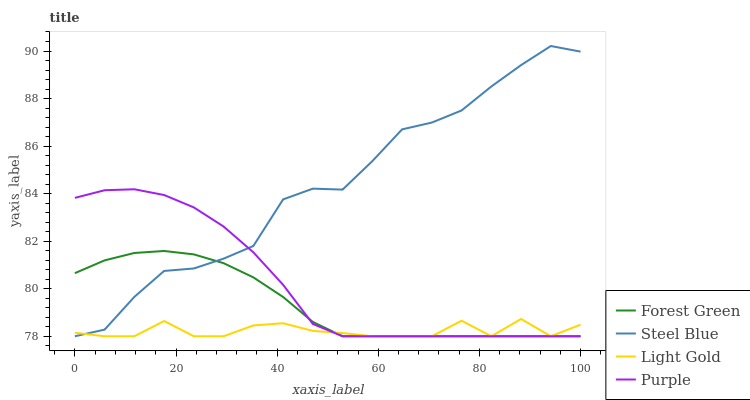Does Light Gold have the minimum area under the curve?
Answer yes or no. Yes. Does Steel Blue have the maximum area under the curve?
Answer yes or no. Yes. Does Forest Green have the minimum area under the curve?
Answer yes or no. No. Does Forest Green have the maximum area under the curve?
Answer yes or no. No. Is Forest Green the smoothest?
Answer yes or no. Yes. Is Steel Blue the roughest?
Answer yes or no. Yes. Is Light Gold the smoothest?
Answer yes or no. No. Is Light Gold the roughest?
Answer yes or no. No. Does Purple have the lowest value?
Answer yes or no. Yes. Does Steel Blue have the highest value?
Answer yes or no. Yes. Does Forest Green have the highest value?
Answer yes or no. No. Does Purple intersect Forest Green?
Answer yes or no. Yes. Is Purple less than Forest Green?
Answer yes or no. No. Is Purple greater than Forest Green?
Answer yes or no. No. 